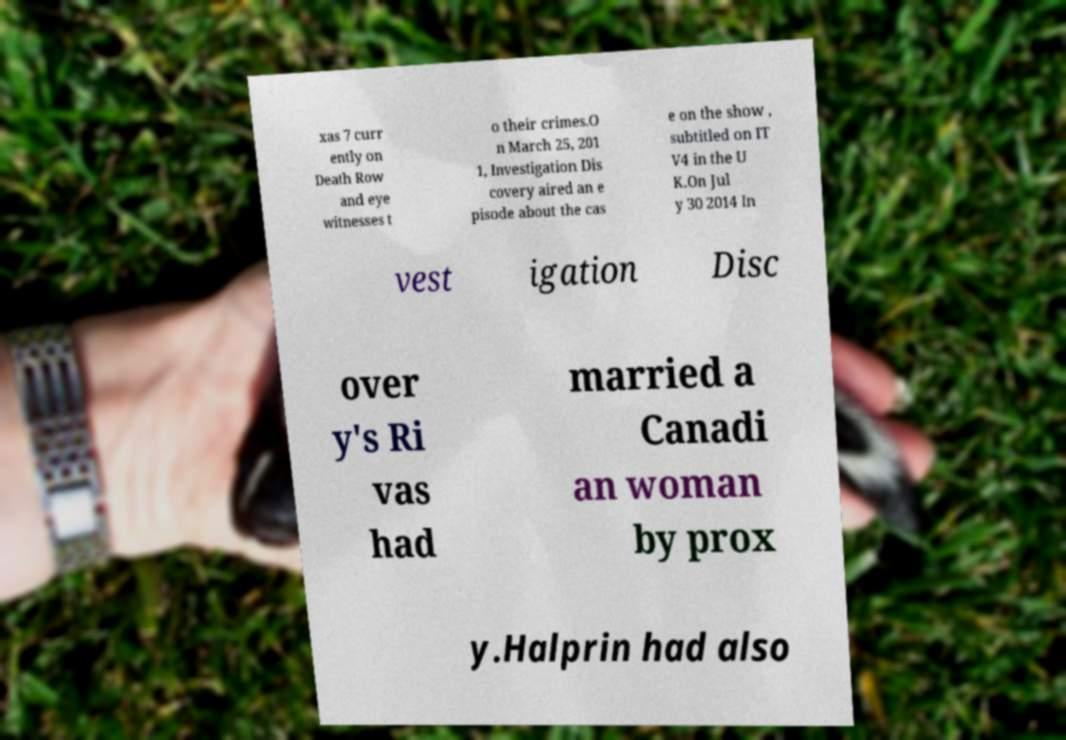Can you accurately transcribe the text from the provided image for me? xas 7 curr ently on Death Row and eye witnesses t o their crimes.O n March 25, 201 1, Investigation Dis covery aired an e pisode about the cas e on the show , subtitled on IT V4 in the U K.On Jul y 30 2014 In vest igation Disc over y's Ri vas had married a Canadi an woman by prox y.Halprin had also 